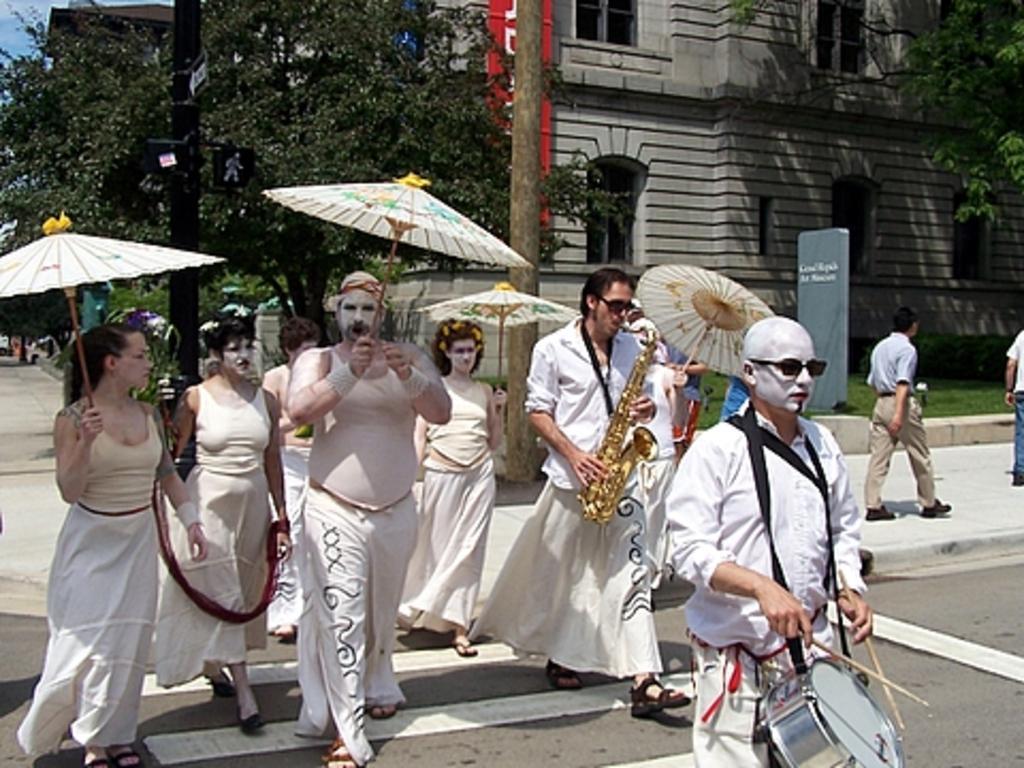Describe this image in one or two sentences. This persons are walking on a road, as there is a leg movement. This 3 persons are holding a umbrella. This are trees. This are buildings with windows. This is a grass. This person is playing a drum with sticks. This is a black pole. 